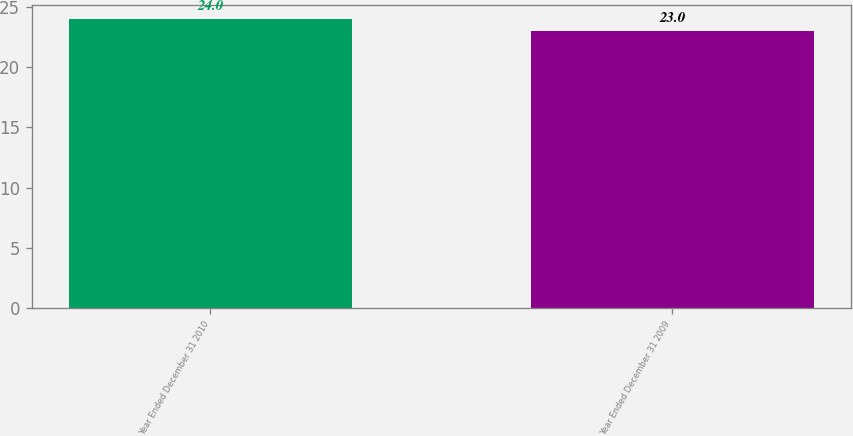Convert chart to OTSL. <chart><loc_0><loc_0><loc_500><loc_500><bar_chart><fcel>Year Ended December 31 2010<fcel>Year Ended December 31 2009<nl><fcel>24<fcel>23<nl></chart> 